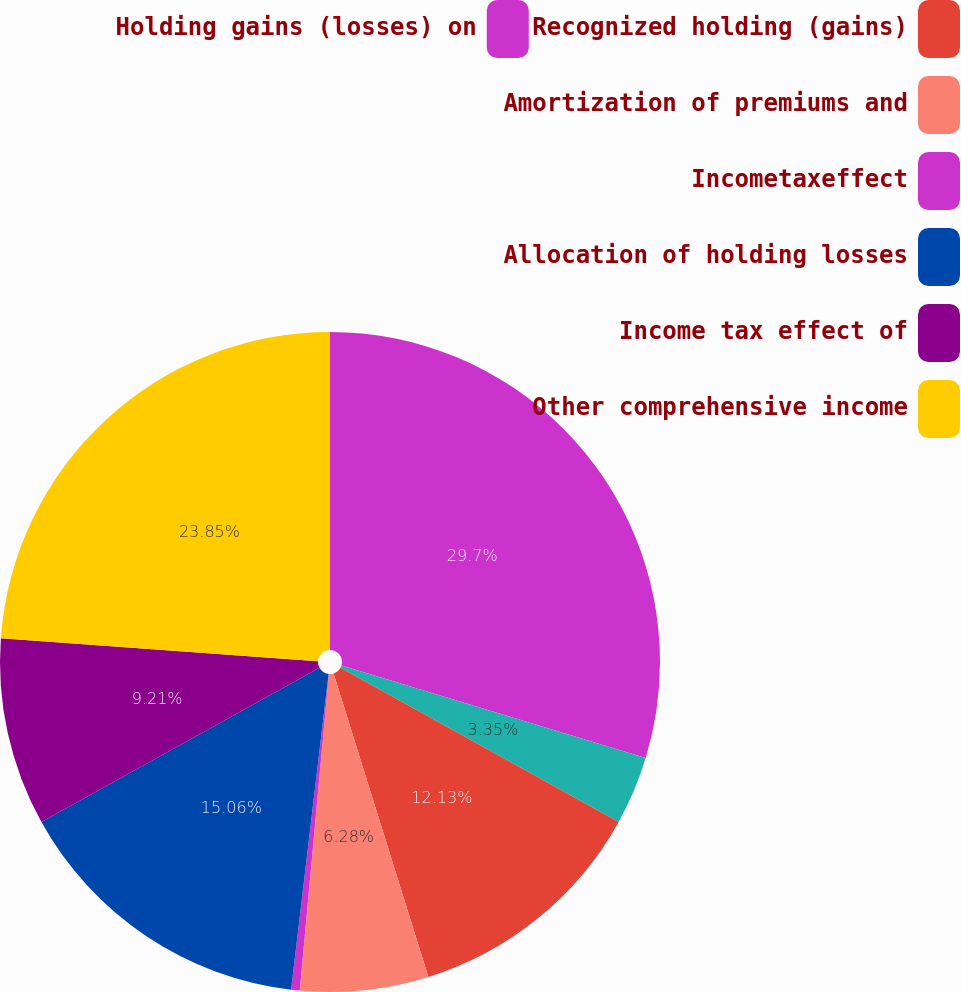<chart> <loc_0><loc_0><loc_500><loc_500><pie_chart><fcel>Holding gains (losses) on<fcel>Unnamed: 1<fcel>Recognized holding (gains)<fcel>Amortization of premiums and<fcel>Incometaxeffect<fcel>Allocation of holding losses<fcel>Income tax effect of<fcel>Other comprehensive income<nl><fcel>29.7%<fcel>3.35%<fcel>12.13%<fcel>6.28%<fcel>0.42%<fcel>15.06%<fcel>9.21%<fcel>23.85%<nl></chart> 